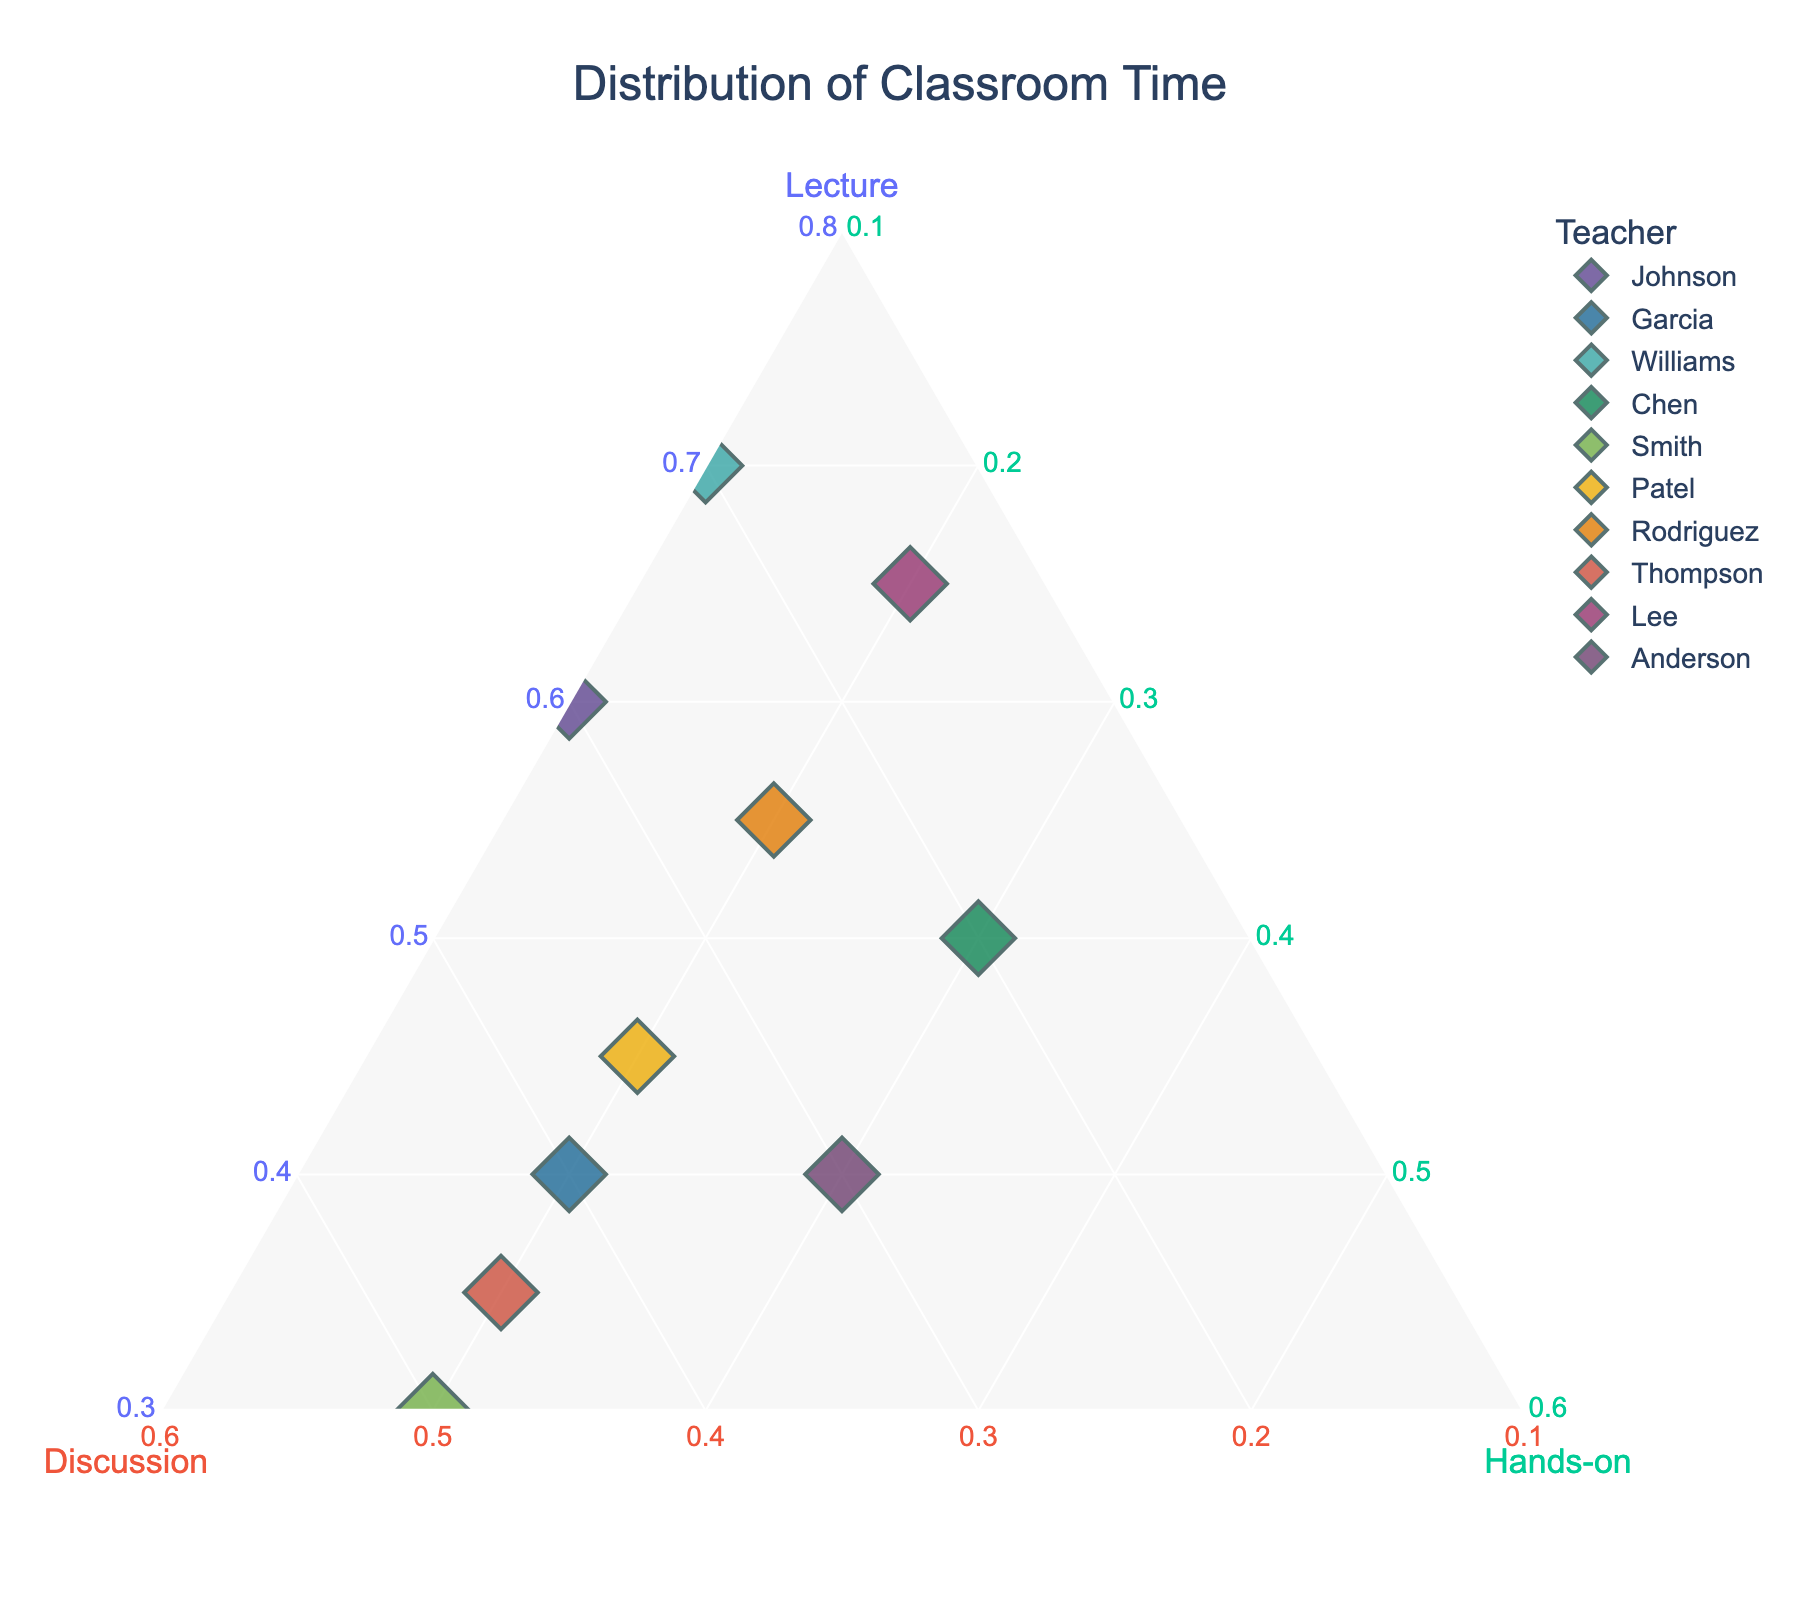What is the title of the figure? The title is typically found at the top of the figure and summarizes the focus of the plot.
Answer: Distribution of Classroom Time How many teachers are represented in the plot? Start by identifying each data point, which represents a teacher on the ternary plot. Count all unique teachers to get the total number.
Answer: 10 Which teacher spends the most time on lectures? Look for the data point closest to the "Lecture" vertex. This represents the teacher with the highest percentage of lecture time.
Answer: Dr. Williams Which teacher has the most balanced approach across lecture, discussion, and hands-on activities? Search for the data point that is most centrally located within the ternary diagram, indicating roughly equal distribution among the three activities.
Answer: Mr. Anderson Which two teachers allocate the same percentage of time to hands-on activities? Identify and compare the hands-on activity percentage for each teacher. Look for pairs with the same percentage.
Answer: Prof. Smith and Dr. Thompson (both 20%) What is the combined percentage of lecture and discussion time for Mrs. Chen? Add the percentages for lecture and discussion from Mrs. Chen's data point.
Answer: 50% + 20% = 70% Who spends more time on discussions, Prof. Smith or Ms. Rodriguez? Compare the data points for Prof. Smith and Ms. Rodriguez based on their discussion percentages.
Answer: Prof. Smith (50% > 25%) Which teacher spends less than 20% of time on hands-on activities? Look for data points with hands-on activity percentages below 20%.
Answer: Ms. Johnson, Dr. Williams, Mrs. Chen How much more time does Dr. Williams spend on lectures compared to discussions? Subtract the percentage of discussion time from the percentage of lecture time for Dr. Williams.
Answer: 70% - 20% = 50% If Mr. Patel and Mr. Anderson were combined, what would be their average hands-on activity time? Add the hands-on percentages for Mr. Patel and Mr. Anderson, then divide by 2 for the average.
Answer: (20% + 30%) / 2 = 25% 